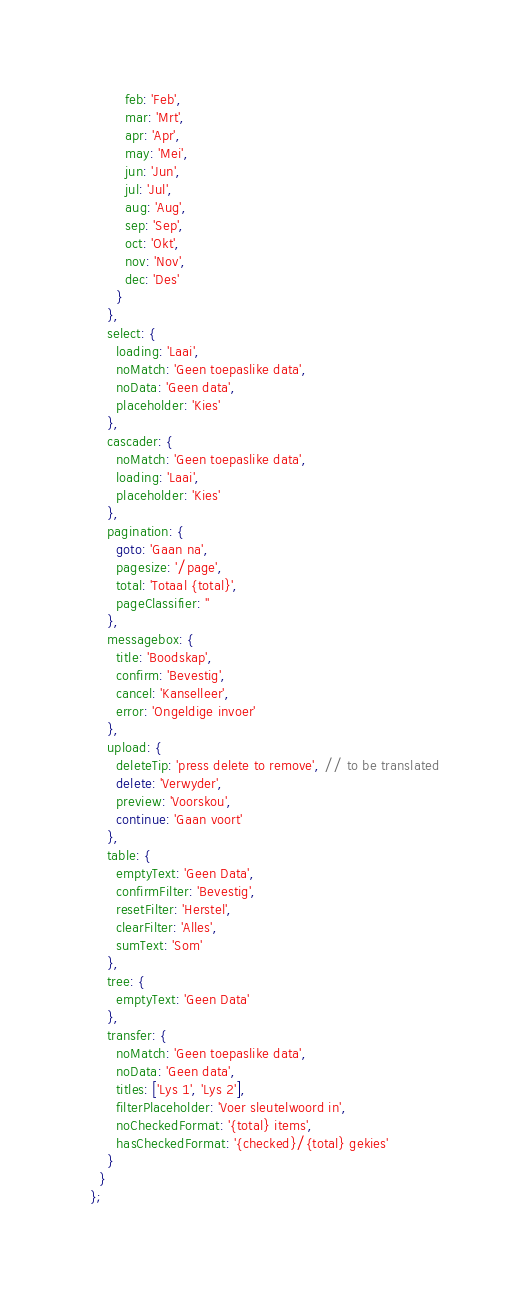<code> <loc_0><loc_0><loc_500><loc_500><_JavaScript_>        feb: 'Feb',
        mar: 'Mrt',
        apr: 'Apr',
        may: 'Mei',
        jun: 'Jun',
        jul: 'Jul',
        aug: 'Aug',
        sep: 'Sep',
        oct: 'Okt',
        nov: 'Nov',
        dec: 'Des'
      }
    },
    select: {
      loading: 'Laai',
      noMatch: 'Geen toepaslike data',
      noData: 'Geen data',
      placeholder: 'Kies'
    },
    cascader: {
      noMatch: 'Geen toepaslike data',
      loading: 'Laai',
      placeholder: 'Kies'
    },
    pagination: {
      goto: 'Gaan na',
      pagesize: '/page',
      total: 'Totaal {total}',
      pageClassifier: ''
    },
    messagebox: {
      title: 'Boodskap',
      confirm: 'Bevestig',
      cancel: 'Kanselleer',
      error: 'Ongeldige invoer'
    },
    upload: {
      deleteTip: 'press delete to remove', // to be translated
      delete: 'Verwyder',
      preview: 'Voorskou',
      continue: 'Gaan voort'
    },
    table: {
      emptyText: 'Geen Data',
      confirmFilter: 'Bevestig',
      resetFilter: 'Herstel',
      clearFilter: 'Alles',
      sumText: 'Som'
    },
    tree: {
      emptyText: 'Geen Data'
    },
    transfer: {
      noMatch: 'Geen toepaslike data',
      noData: 'Geen data',
      titles: ['Lys 1', 'Lys 2'],
      filterPlaceholder: 'Voer sleutelwoord in',
      noCheckedFormat: '{total} items',
      hasCheckedFormat: '{checked}/{total} gekies'
    }
  }
};</code> 